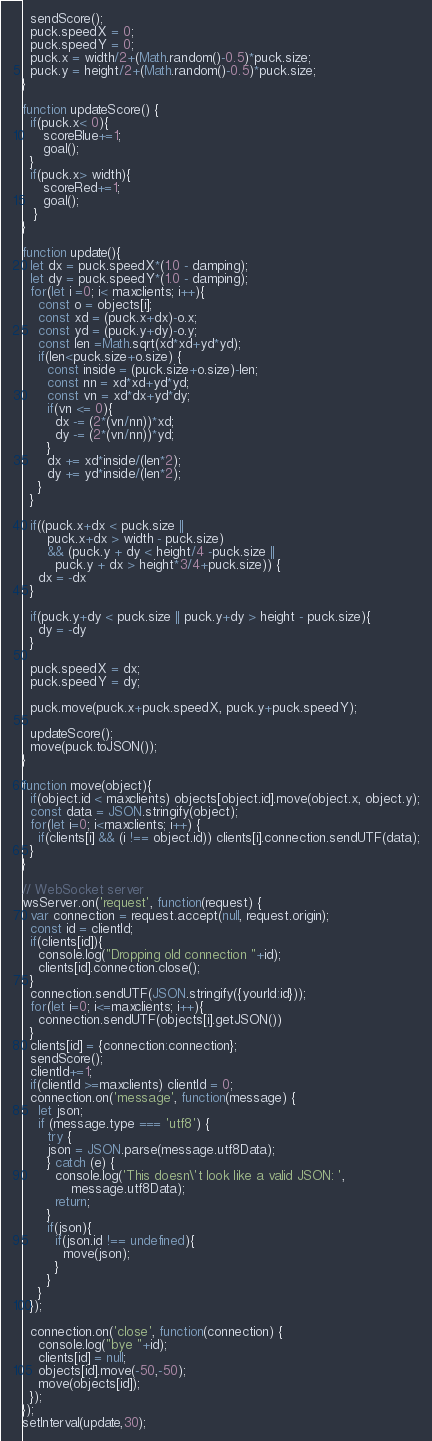Convert code to text. <code><loc_0><loc_0><loc_500><loc_500><_JavaScript_>  sendScore();
  puck.speedX = 0;
  puck.speedY = 0;
  puck.x = width/2+(Math.random()-0.5)*puck.size;
  puck.y = height/2+(Math.random()-0.5)*puck.size;
}

function updateScore() {
  if(puck.x< 0){
     scoreBlue+=1;
     goal();
  }
  if(puck.x> width){
     scoreRed+=1;
     goal();
   }
}

function update(){
  let dx = puck.speedX*(1.0 - damping);
  let dy = puck.speedY*(1.0 - damping);
  for(let i =0; i< maxclients; i++){
    const o = objects[i];
    const xd = (puck.x+dx)-o.x;
    const yd = (puck.y+dy)-o.y;
    const len =Math.sqrt(xd*xd+yd*yd);
    if(len<puck.size+o.size) {
      const inside = (puck.size+o.size)-len;
      const nn = xd*xd+yd*yd;
      const vn = xd*dx+yd*dy;
      if(vn <= 0){
        dx -= (2*(vn/nn))*xd;
        dy -= (2*(vn/nn))*yd;
      }
      dx += xd*inside/(len*2);
      dy += yd*inside/(len*2);
    }
  }

  if((puck.x+dx < puck.size ||
      puck.x+dx > width - puck.size)
      && (puck.y + dy < height/4 -puck.size ||
        puck.y + dx > height*3/4+puck.size)) {
    dx = -dx
  }

  if(puck.y+dy < puck.size || puck.y+dy > height - puck.size){
    dy = -dy
  }

  puck.speedX = dx;
  puck.speedY = dy;

  puck.move(puck.x+puck.speedX, puck.y+puck.speedY);

  updateScore();
  move(puck.toJSON());
}

function move(object){
  if(object.id < maxclients) objects[object.id].move(object.x, object.y);
  const data = JSON.stringify(object);
  for(let i=0; i<maxclients; i++) {
    if(clients[i] && (i !== object.id)) clients[i].connection.sendUTF(data);
  }
}

// WebSocket server
wsServer.on('request', function(request) {
  var connection = request.accept(null, request.origin);
  const id = clientId;
  if(clients[id]){
    console.log("Dropping old connection "+id);
    clients[id].connection.close();
  }
  connection.sendUTF(JSON.stringify({yourId:id}));
  for(let i=0; i<=maxclients; i++){
    connection.sendUTF(objects[i].getJSON())
  }
  clients[id] = {connection:connection};
  sendScore();
  clientId+=1;
  if(clientId >=maxclients) clientId = 0;
  connection.on('message', function(message) {
    let json;
    if (message.type === 'utf8') {
      try {
      json = JSON.parse(message.utf8Data);
      } catch (e) {
        console.log('This doesn\'t look like a valid JSON: ',
            message.utf8Data);
        return;
      }
      if(json){
        if(json.id !== undefined){
          move(json);
        }
      }
    }
  });

  connection.on('close', function(connection) {
    console.log("bye "+id);
    clients[id] = null;
    objects[id].move(-50,-50);
    move(objects[id]);
  });
});
setInterval(update,30);
</code> 